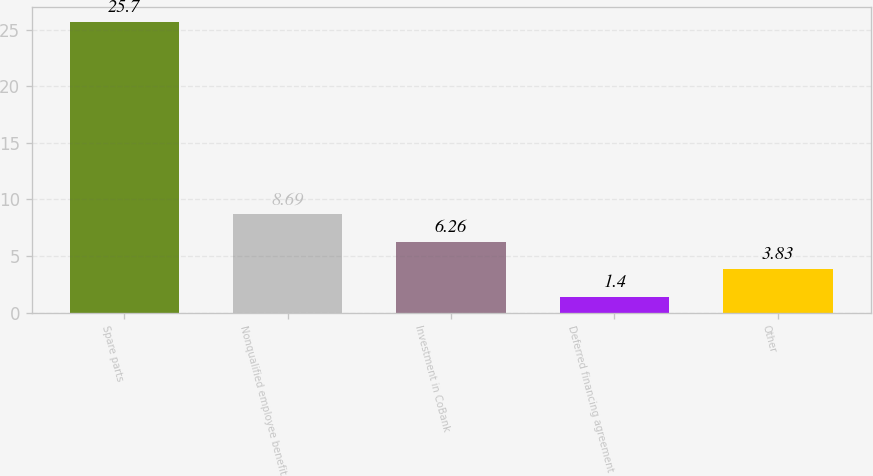Convert chart. <chart><loc_0><loc_0><loc_500><loc_500><bar_chart><fcel>Spare parts<fcel>Nonqualified employee benefit<fcel>Investment in CoBank<fcel>Deferred financing agreement<fcel>Other<nl><fcel>25.7<fcel>8.69<fcel>6.26<fcel>1.4<fcel>3.83<nl></chart> 